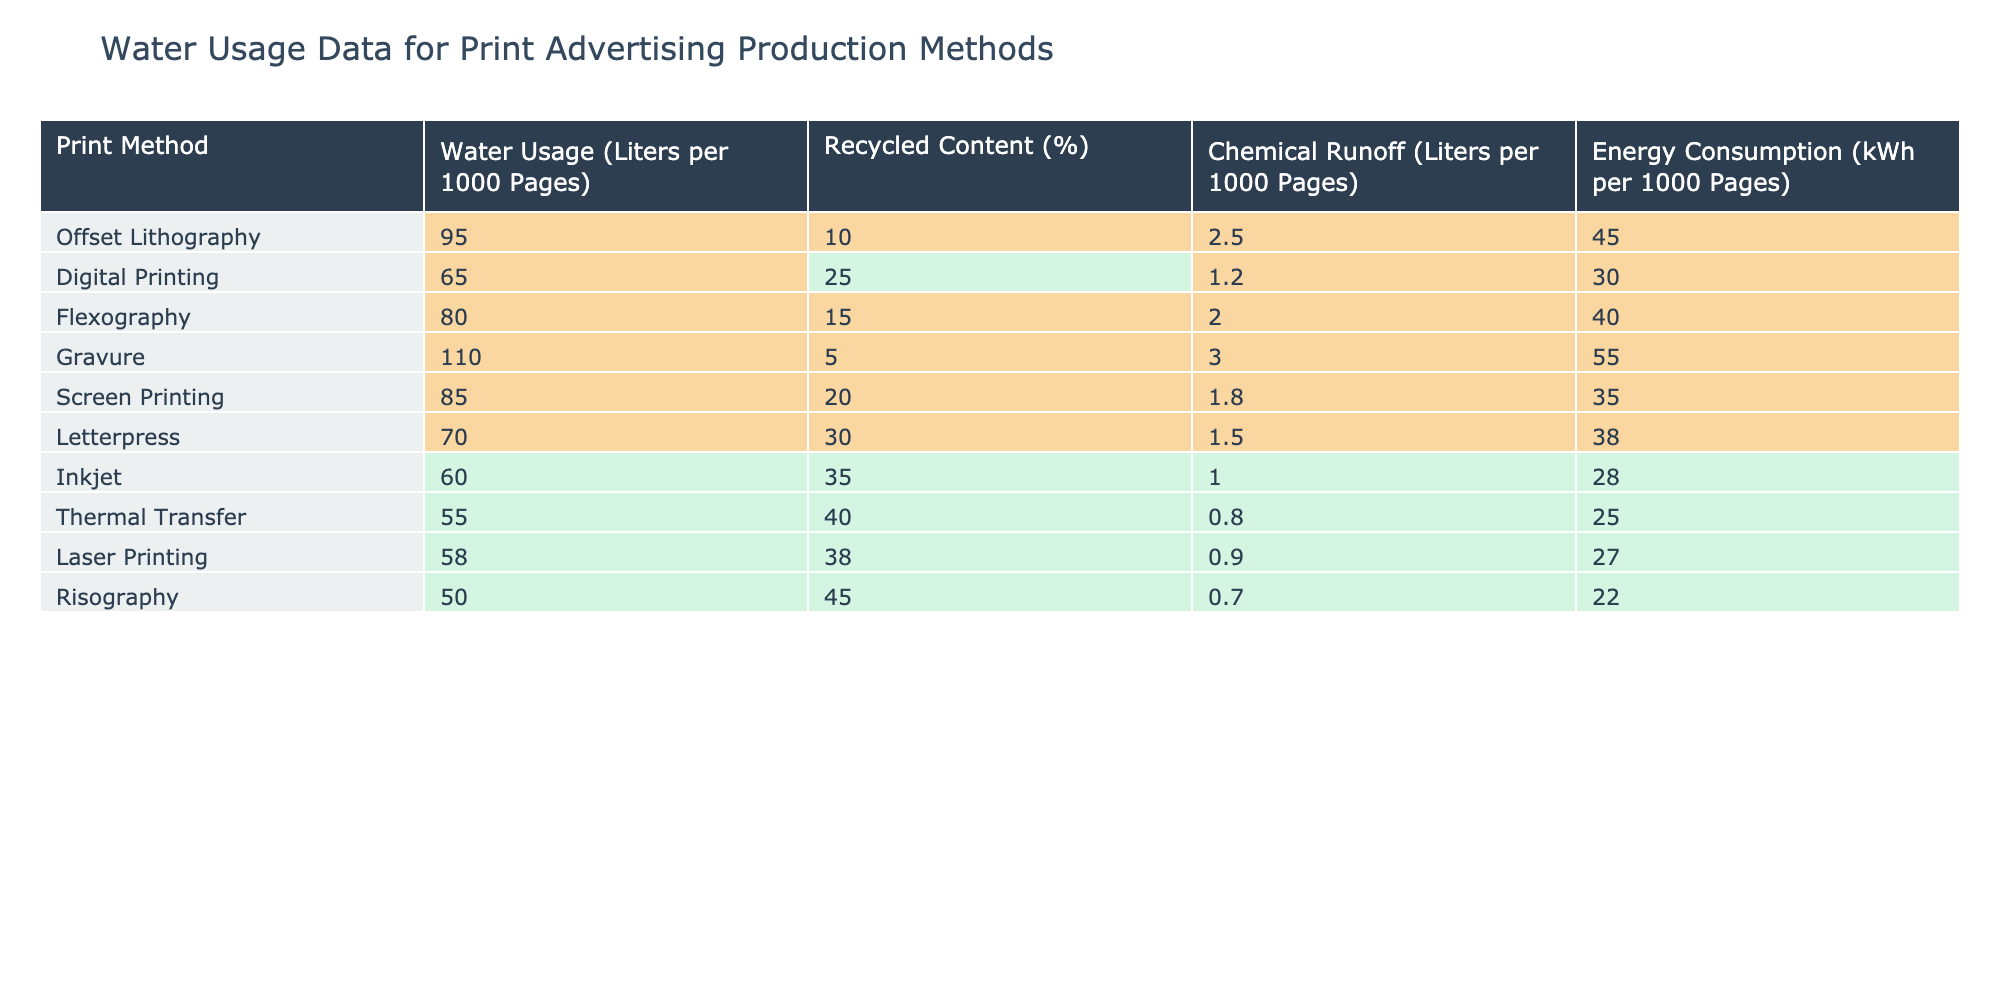What is the water usage for Digital Printing? According to the table, the water usage for Digital Printing is listed as 65 liters per 1000 pages.
Answer: 65 liters Which print method has the highest water usage? The table shows that Gravure has the highest water usage of 110 liters per 1000 pages.
Answer: Gravure What is the recycled content percentage for Inkjet printing? The recycled content for Inkjet printing is recorded as 35%.
Answer: 35% Calculate the average chemical runoff for all print methods. To find the average, sum the chemical runoff values: 2.5 + 1.2 + 2.0 + 3.0 + 1.8 + 1.5 + 1.0 + 0.8 + 0.9 + 0.7 = 15.6. There are 10 print methods, so the average is 15.6 / 10 = 1.56.
Answer: 1.56 liters Is the energy consumption for Thermal Transfer lower than that for Letterpress? Thermal Transfer's energy consumption is 25 kWh, while Letterpress is at 38 kWh. Since 25 is less than 38, the statement is true.
Answer: Yes Which print methods have both recycled content above 30% and water usage below 70 liters? The only print method that meets both criteria is Inkjet, which has 35% recycled content and 60 liters of water usage.
Answer: Inkjet If we combine the water usage of Offset Lithography and Flexography, what would the total be? Offset Lithography water usage is 95 liters and Flexography is 80 liters. Adding them gives us 95 + 80 = 175 liters total.
Answer: 175 liters Does the print method with the least amount of water usage also have the highest recycled content? The print method with the least water usage is Risography with 50 liters, and it has 45% recycled content. The highest recycled content is for Thermal Transfer at 40%, which does not apply here, so the statement is false.
Answer: No Which printing method uses the least energy, and what is its value? The table shows that Risography uses the least energy at 22 kWh per 1000 pages.
Answer: 22 kWh Determine the difference in water usage between Gravure and Inkjet printing. Gravure uses 110 liters and Inkjet uses 60 liters. To find the difference: 110 - 60 = 50 liters.
Answer: 50 liters 